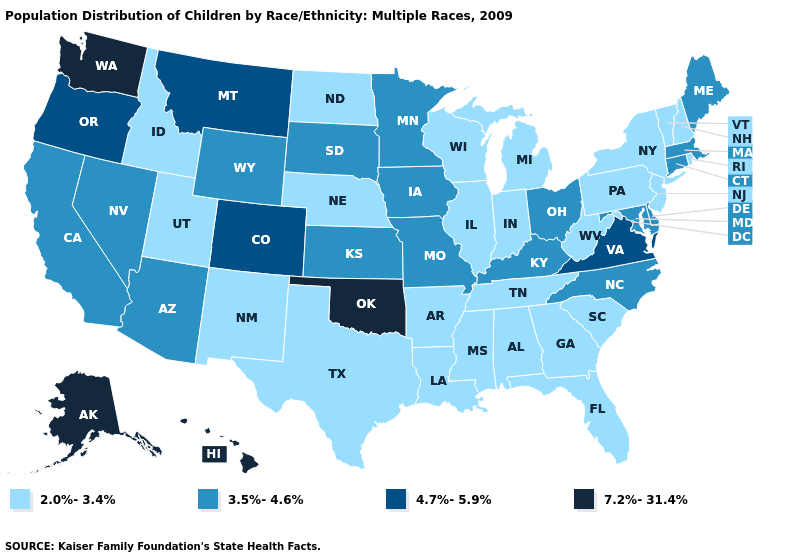What is the lowest value in the USA?
Short answer required. 2.0%-3.4%. How many symbols are there in the legend?
Be succinct. 4. Which states have the lowest value in the USA?
Concise answer only. Alabama, Arkansas, Florida, Georgia, Idaho, Illinois, Indiana, Louisiana, Michigan, Mississippi, Nebraska, New Hampshire, New Jersey, New Mexico, New York, North Dakota, Pennsylvania, Rhode Island, South Carolina, Tennessee, Texas, Utah, Vermont, West Virginia, Wisconsin. Is the legend a continuous bar?
Answer briefly. No. Among the states that border Wisconsin , which have the lowest value?
Give a very brief answer. Illinois, Michigan. Among the states that border Illinois , does Kentucky have the highest value?
Be succinct. Yes. Name the states that have a value in the range 4.7%-5.9%?
Concise answer only. Colorado, Montana, Oregon, Virginia. Does Rhode Island have the highest value in the USA?
Answer briefly. No. What is the value of Oregon?
Keep it brief. 4.7%-5.9%. Name the states that have a value in the range 4.7%-5.9%?
Give a very brief answer. Colorado, Montana, Oregon, Virginia. Name the states that have a value in the range 4.7%-5.9%?
Quick response, please. Colorado, Montana, Oregon, Virginia. Among the states that border Indiana , which have the lowest value?
Write a very short answer. Illinois, Michigan. Does the first symbol in the legend represent the smallest category?
Quick response, please. Yes. Among the states that border South Dakota , does Montana have the highest value?
Keep it brief. Yes. Name the states that have a value in the range 2.0%-3.4%?
Give a very brief answer. Alabama, Arkansas, Florida, Georgia, Idaho, Illinois, Indiana, Louisiana, Michigan, Mississippi, Nebraska, New Hampshire, New Jersey, New Mexico, New York, North Dakota, Pennsylvania, Rhode Island, South Carolina, Tennessee, Texas, Utah, Vermont, West Virginia, Wisconsin. 